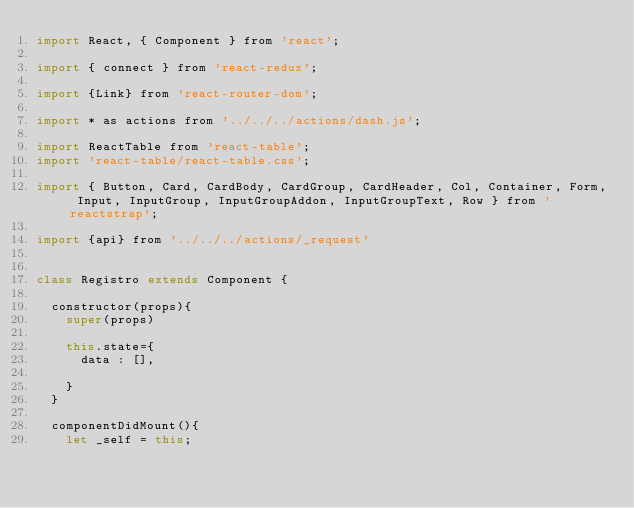Convert code to text. <code><loc_0><loc_0><loc_500><loc_500><_JavaScript_>import React, { Component } from 'react';

import { connect } from 'react-redux';

import {Link} from 'react-router-dom';

import * as actions from '../../../actions/dash.js';

import ReactTable from 'react-table';
import 'react-table/react-table.css';

import { Button, Card, CardBody, CardGroup, CardHeader, Col, Container, Form, Input, InputGroup, InputGroupAddon, InputGroupText, Row } from 'reactstrap';

import {api} from '../../../actions/_request'


class Registro extends Component {

	constructor(props){
		super(props)

		this.state={
			data : [],
			    
		}
	}

	componentDidMount(){
		let _self = this;</code> 